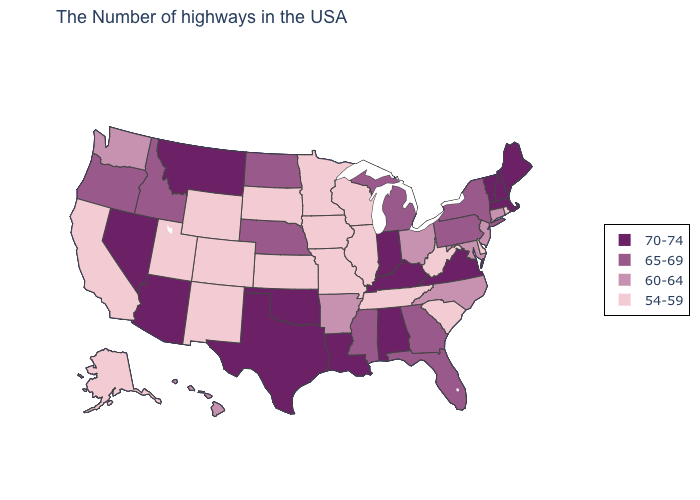Among the states that border South Dakota , which have the highest value?
Write a very short answer. Montana. What is the highest value in the USA?
Keep it brief. 70-74. How many symbols are there in the legend?
Concise answer only. 4. What is the lowest value in the USA?
Short answer required. 54-59. Does Wyoming have the highest value in the USA?
Give a very brief answer. No. Name the states that have a value in the range 54-59?
Give a very brief answer. Rhode Island, Delaware, South Carolina, West Virginia, Tennessee, Wisconsin, Illinois, Missouri, Minnesota, Iowa, Kansas, South Dakota, Wyoming, Colorado, New Mexico, Utah, California, Alaska. What is the value of Virginia?
Keep it brief. 70-74. Does the map have missing data?
Short answer required. No. Among the states that border Maryland , does Virginia have the highest value?
Keep it brief. Yes. Name the states that have a value in the range 54-59?
Give a very brief answer. Rhode Island, Delaware, South Carolina, West Virginia, Tennessee, Wisconsin, Illinois, Missouri, Minnesota, Iowa, Kansas, South Dakota, Wyoming, Colorado, New Mexico, Utah, California, Alaska. Name the states that have a value in the range 65-69?
Concise answer only. New York, Pennsylvania, Florida, Georgia, Michigan, Mississippi, Nebraska, North Dakota, Idaho, Oregon. Which states hav the highest value in the Northeast?
Write a very short answer. Maine, Massachusetts, New Hampshire, Vermont. What is the value of Wyoming?
Quick response, please. 54-59. Does Vermont have the same value as Arizona?
Keep it brief. Yes. Name the states that have a value in the range 70-74?
Give a very brief answer. Maine, Massachusetts, New Hampshire, Vermont, Virginia, Kentucky, Indiana, Alabama, Louisiana, Oklahoma, Texas, Montana, Arizona, Nevada. 